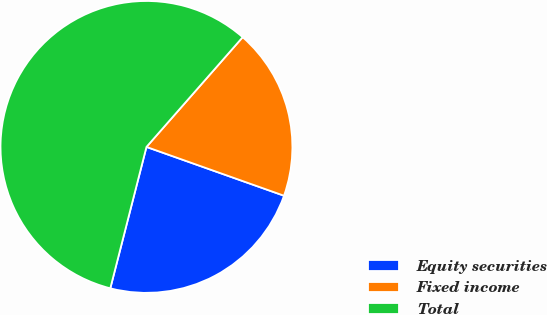Convert chart. <chart><loc_0><loc_0><loc_500><loc_500><pie_chart><fcel>Equity securities<fcel>Fixed income<fcel>Total<nl><fcel>23.56%<fcel>18.97%<fcel>57.47%<nl></chart> 